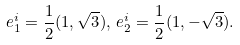Convert formula to latex. <formula><loc_0><loc_0><loc_500><loc_500>e _ { 1 } ^ { i } = \frac { 1 } { 2 } ( 1 , \sqrt { 3 } ) , \, e _ { 2 } ^ { i } = \frac { 1 } { 2 } ( 1 , - \sqrt { 3 } ) .</formula> 